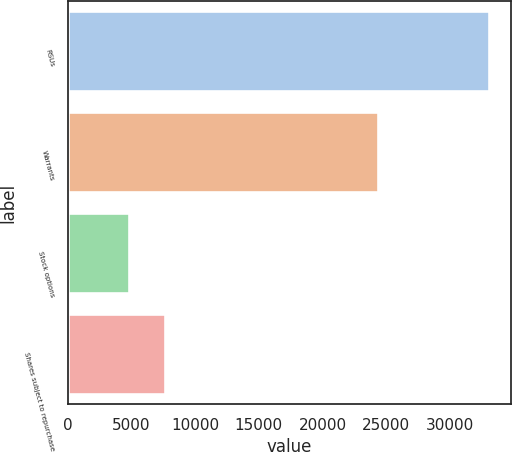Convert chart to OTSL. <chart><loc_0><loc_0><loc_500><loc_500><bar_chart><fcel>RSUs<fcel>Warrants<fcel>Stock options<fcel>Shares subject to repurchase<nl><fcel>33123<fcel>24329<fcel>4793<fcel>7626<nl></chart> 